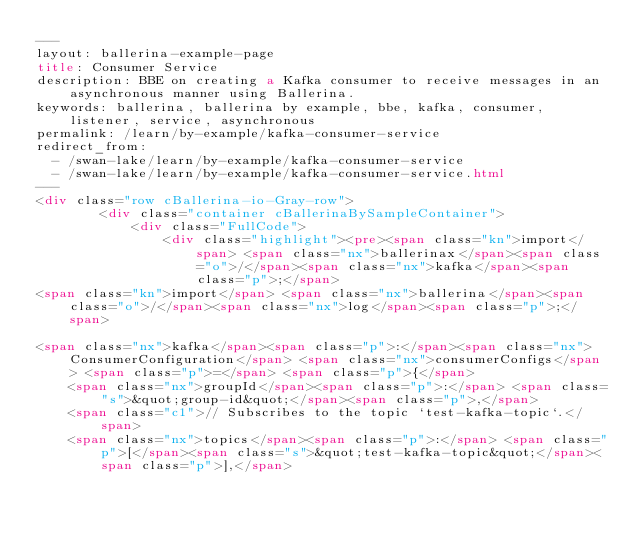<code> <loc_0><loc_0><loc_500><loc_500><_HTML_>---
layout: ballerina-example-page
title: Consumer Service
description: BBE on creating a Kafka consumer to receive messages in an asynchronous manner using Ballerina.
keywords: ballerina, ballerina by example, bbe, kafka, consumer, listener, service, asynchronous
permalink: /learn/by-example/kafka-consumer-service
redirect_from:
  - /swan-lake/learn/by-example/kafka-consumer-service
  - /swan-lake/learn/by-example/kafka-consumer-service.html
---
<div class="row cBallerina-io-Gray-row">
        <div class="container cBallerinaBySampleContainer">
            <div class="FullCode">
                <div class="highlight"><pre><span class="kn">import</span> <span class="nx">ballerinax</span><span class="o">/</span><span class="nx">kafka</span><span class="p">;</span>
<span class="kn">import</span> <span class="nx">ballerina</span><span class="o">/</span><span class="nx">log</span><span class="p">;</span>

<span class="nx">kafka</span><span class="p">:</span><span class="nx">ConsumerConfiguration</span> <span class="nx">consumerConfigs</span> <span class="p">=</span> <span class="p">{</span>
    <span class="nx">groupId</span><span class="p">:</span> <span class="s">&quot;group-id&quot;</span><span class="p">,</span>
    <span class="c1">// Subscribes to the topic `test-kafka-topic`.</span>
    <span class="nx">topics</span><span class="p">:</span> <span class="p">[</span><span class="s">&quot;test-kafka-topic&quot;</span><span class="p">],</span>
</code> 